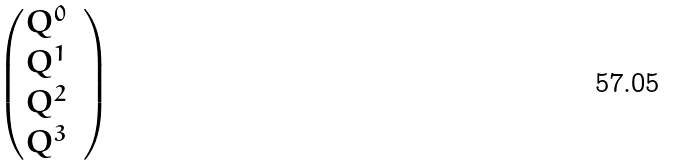Convert formula to latex. <formula><loc_0><loc_0><loc_500><loc_500>\begin{pmatrix} Q ^ { 0 } & \\ Q ^ { 1 } \\ Q ^ { 2 } \\ Q ^ { 3 } \end{pmatrix}</formula> 